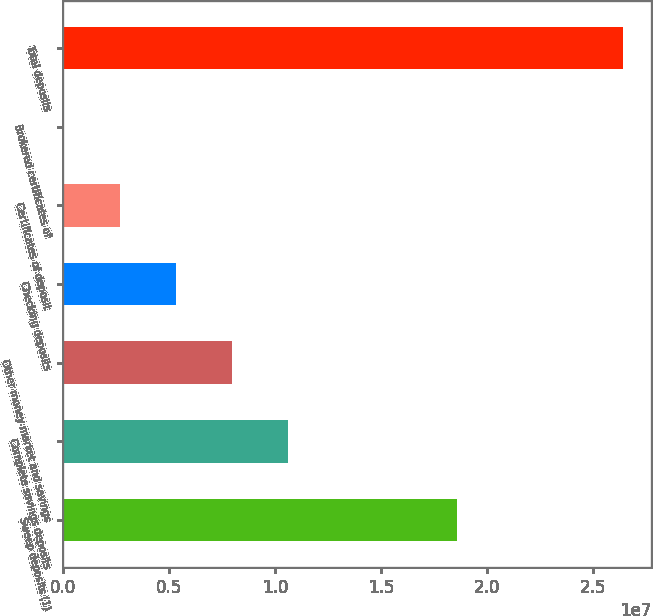Convert chart. <chart><loc_0><loc_0><loc_500><loc_500><bar_chart><fcel>Sweep deposits (1)<fcel>Complete savings deposits<fcel>Other money market and savings<fcel>Checking deposits<fcel>Certificates of deposit<fcel>Brokered certificates of<fcel>Total deposits<nl><fcel>1.8619e+07<fcel>1.06039e+07<fcel>7.96125e+06<fcel>5.31858e+06<fcel>2.6759e+06<fcel>33226<fcel>2.646e+07<nl></chart> 